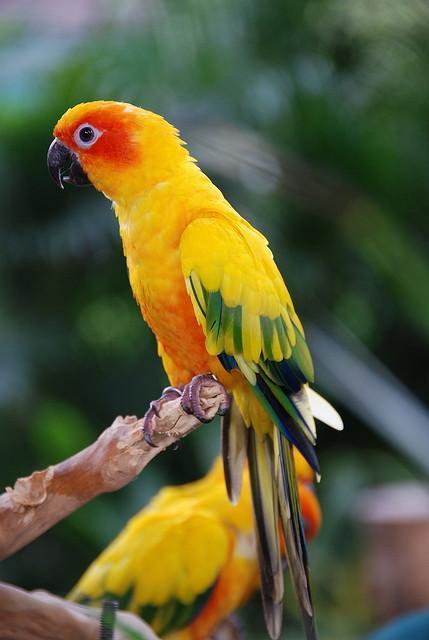How many birds are in this picture?
Give a very brief answer. 2. How many birds are there?
Give a very brief answer. 2. 